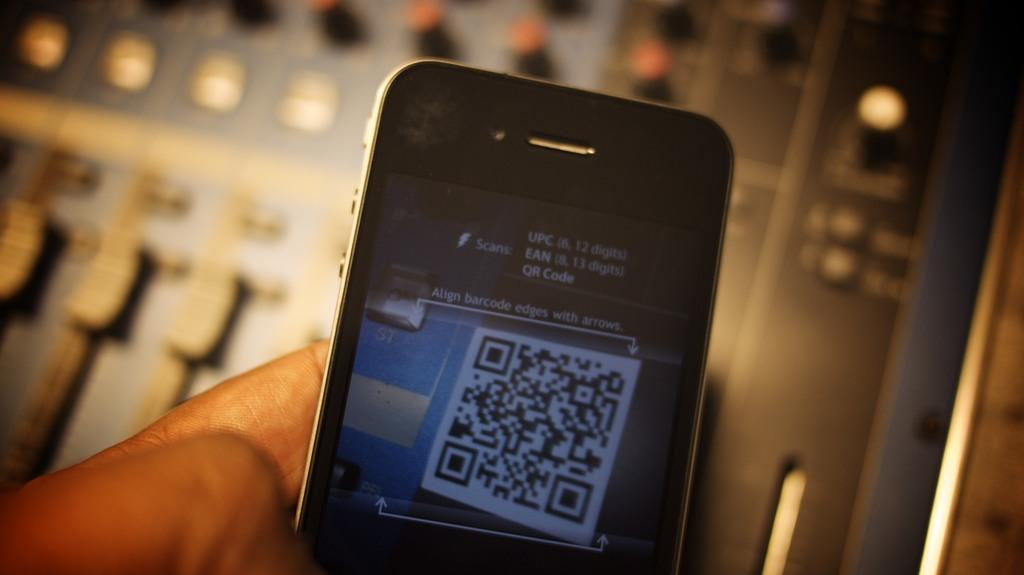<image>
Give a short and clear explanation of the subsequent image. a close up of a cell phone with words on the screen Align Barcode 